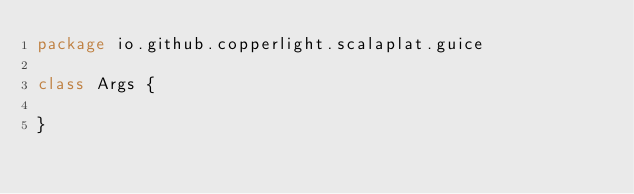Convert code to text. <code><loc_0><loc_0><loc_500><loc_500><_Scala_>package io.github.copperlight.scalaplat.guice

class Args {

}
</code> 